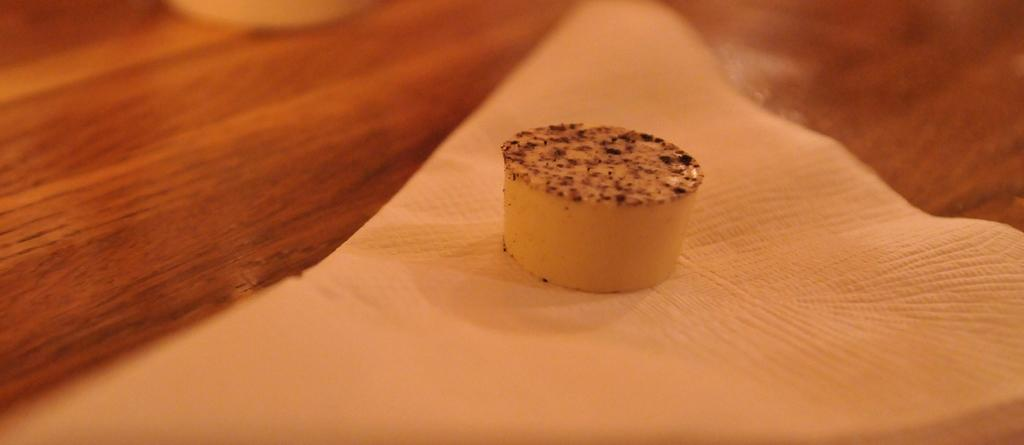What is present in the image related to food? There is food in the image. How is the food arranged or presented? The food is on a napkin. Where is the napkin with food located? The napkin with food is on a table. What type of jewel can be seen in the image? There is no jewel present in the image; it features food on a napkin on a table. 